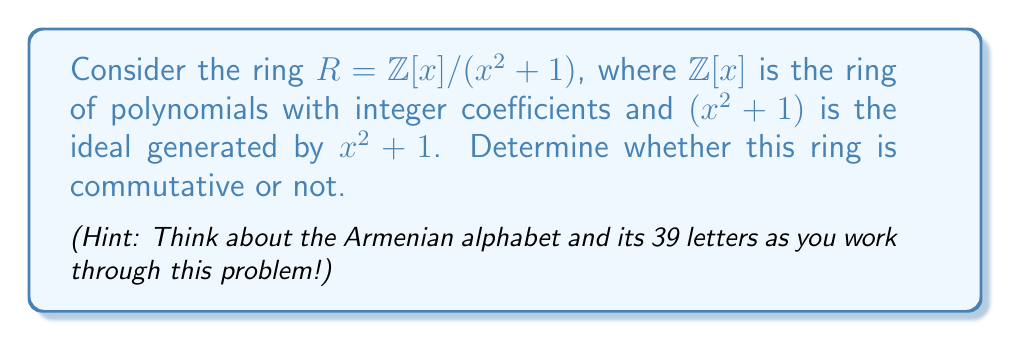Teach me how to tackle this problem. Let's approach this step-by-step:

1) First, recall that a ring $R$ is commutative if for all $a, b \in R$, we have $ab = ba$.

2) In this case, $R = \mathbb{Z}[x]/(x^2 + 1)$ is the quotient ring of $\mathbb{Z}[x]$ by the ideal generated by $x^2 + 1$.

3) Elements of $R$ are of the form $a + bx$, where $a, b \in \mathbb{Z}$ and $x^2 = -1$ in $R$.

4) To prove commutativity, we need to show that for any two elements $a + bx$ and $c + dx$ in $R$, their product is commutative.

5) Let's multiply these elements:

   $(a + bx)(c + dx) = ac + adx + bcx + bdx^2$
                     $= ac + (ad + bc)x + bd(-1)$
                     $= (ac - bd) + (ad + bc)x$

6) Now, let's multiply in the reverse order:

   $(c + dx)(a + bx) = ca + cbx + dax + dbx^2$
                     $= ca + (cb + da)x + db(-1)$
                     $= (ca - db) + (cb + da)x$

7) We can see that $(ac - bd) = (ca - db)$ and $(ad + bc) = (cb + da)$ for all $a, b, c, d \in \mathbb{Z}$.

8) This means that $(a + bx)(c + dx) = (c + dx)(a + bx)$ for all elements in $R$.

Therefore, the ring $R = \mathbb{Z}[x]/(x^2 + 1)$ is commutative.
Answer: Yes, $\mathbb{Z}[x]/(x^2 + 1)$ is commutative. 